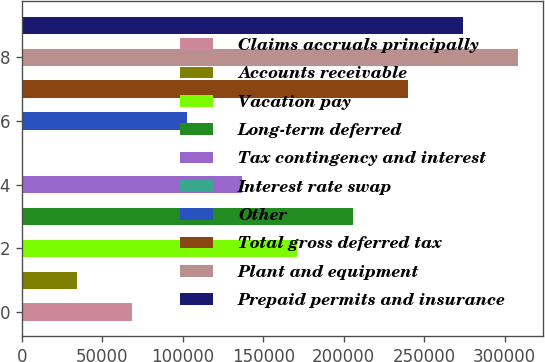Convert chart to OTSL. <chart><loc_0><loc_0><loc_500><loc_500><bar_chart><fcel>Claims accruals principally<fcel>Accounts receivable<fcel>Vacation pay<fcel>Long-term deferred<fcel>Tax contingency and interest<fcel>Interest rate swap<fcel>Other<fcel>Total gross deferred tax<fcel>Plant and equipment<fcel>Prepaid permits and insurance<nl><fcel>68551<fcel>34323<fcel>171235<fcel>205463<fcel>137007<fcel>95<fcel>102779<fcel>239691<fcel>308147<fcel>273919<nl></chart> 